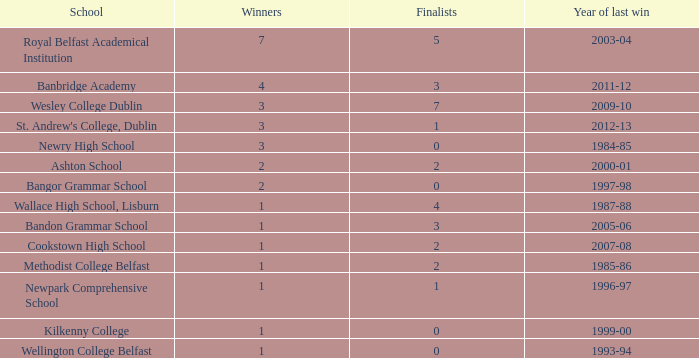What are the names that had a finalist score of 2? Ashton School, Cookstown High School, Methodist College Belfast. 